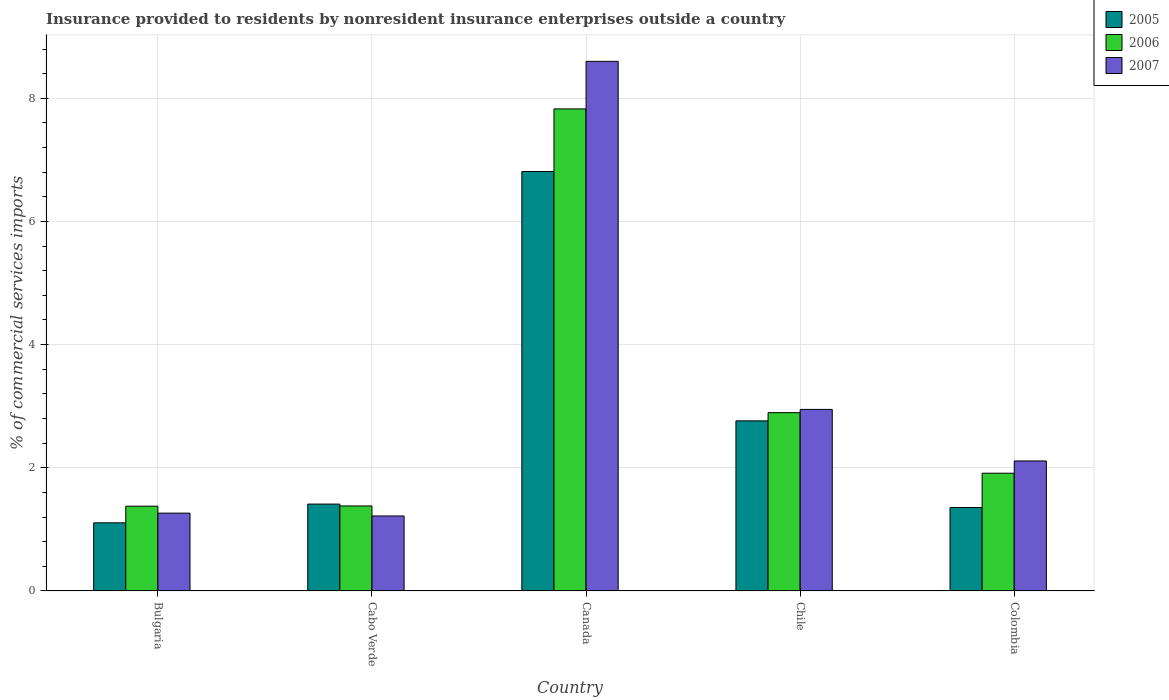How many groups of bars are there?
Your response must be concise. 5. Are the number of bars on each tick of the X-axis equal?
Provide a short and direct response. Yes. How many bars are there on the 5th tick from the left?
Provide a succinct answer. 3. How many bars are there on the 5th tick from the right?
Provide a short and direct response. 3. What is the label of the 4th group of bars from the left?
Provide a succinct answer. Chile. In how many cases, is the number of bars for a given country not equal to the number of legend labels?
Provide a short and direct response. 0. What is the Insurance provided to residents in 2006 in Cabo Verde?
Offer a very short reply. 1.38. Across all countries, what is the maximum Insurance provided to residents in 2006?
Ensure brevity in your answer.  7.83. Across all countries, what is the minimum Insurance provided to residents in 2006?
Ensure brevity in your answer.  1.38. In which country was the Insurance provided to residents in 2007 minimum?
Offer a terse response. Cabo Verde. What is the total Insurance provided to residents in 2005 in the graph?
Your answer should be compact. 13.44. What is the difference between the Insurance provided to residents in 2007 in Bulgaria and that in Chile?
Provide a succinct answer. -1.68. What is the difference between the Insurance provided to residents in 2007 in Chile and the Insurance provided to residents in 2006 in Bulgaria?
Make the answer very short. 1.57. What is the average Insurance provided to residents in 2006 per country?
Keep it short and to the point. 3.08. What is the difference between the Insurance provided to residents of/in 2007 and Insurance provided to residents of/in 2006 in Cabo Verde?
Provide a succinct answer. -0.16. What is the ratio of the Insurance provided to residents in 2005 in Cabo Verde to that in Canada?
Offer a terse response. 0.21. Is the difference between the Insurance provided to residents in 2007 in Chile and Colombia greater than the difference between the Insurance provided to residents in 2006 in Chile and Colombia?
Offer a terse response. No. What is the difference between the highest and the second highest Insurance provided to residents in 2007?
Your response must be concise. 5.65. What is the difference between the highest and the lowest Insurance provided to residents in 2006?
Keep it short and to the point. 6.45. In how many countries, is the Insurance provided to residents in 2005 greater than the average Insurance provided to residents in 2005 taken over all countries?
Your response must be concise. 2. Is the sum of the Insurance provided to residents in 2005 in Bulgaria and Colombia greater than the maximum Insurance provided to residents in 2007 across all countries?
Offer a very short reply. No. What does the 1st bar from the right in Cabo Verde represents?
Provide a succinct answer. 2007. Is it the case that in every country, the sum of the Insurance provided to residents in 2007 and Insurance provided to residents in 2005 is greater than the Insurance provided to residents in 2006?
Keep it short and to the point. Yes. How many countries are there in the graph?
Make the answer very short. 5. Are the values on the major ticks of Y-axis written in scientific E-notation?
Ensure brevity in your answer.  No. Does the graph contain any zero values?
Keep it short and to the point. No. Where does the legend appear in the graph?
Provide a succinct answer. Top right. How many legend labels are there?
Give a very brief answer. 3. How are the legend labels stacked?
Your response must be concise. Vertical. What is the title of the graph?
Offer a terse response. Insurance provided to residents by nonresident insurance enterprises outside a country. Does "1997" appear as one of the legend labels in the graph?
Offer a very short reply. No. What is the label or title of the Y-axis?
Offer a very short reply. % of commercial services imports. What is the % of commercial services imports in 2005 in Bulgaria?
Give a very brief answer. 1.11. What is the % of commercial services imports of 2006 in Bulgaria?
Your response must be concise. 1.38. What is the % of commercial services imports in 2007 in Bulgaria?
Your answer should be very brief. 1.26. What is the % of commercial services imports of 2005 in Cabo Verde?
Your answer should be very brief. 1.41. What is the % of commercial services imports of 2006 in Cabo Verde?
Ensure brevity in your answer.  1.38. What is the % of commercial services imports of 2007 in Cabo Verde?
Provide a short and direct response. 1.22. What is the % of commercial services imports of 2005 in Canada?
Your answer should be very brief. 6.81. What is the % of commercial services imports in 2006 in Canada?
Provide a succinct answer. 7.83. What is the % of commercial services imports of 2007 in Canada?
Provide a short and direct response. 8.6. What is the % of commercial services imports of 2005 in Chile?
Offer a very short reply. 2.76. What is the % of commercial services imports of 2006 in Chile?
Your answer should be compact. 2.89. What is the % of commercial services imports of 2007 in Chile?
Your response must be concise. 2.95. What is the % of commercial services imports in 2005 in Colombia?
Ensure brevity in your answer.  1.35. What is the % of commercial services imports in 2006 in Colombia?
Keep it short and to the point. 1.91. What is the % of commercial services imports of 2007 in Colombia?
Offer a very short reply. 2.11. Across all countries, what is the maximum % of commercial services imports in 2005?
Provide a short and direct response. 6.81. Across all countries, what is the maximum % of commercial services imports of 2006?
Offer a terse response. 7.83. Across all countries, what is the maximum % of commercial services imports of 2007?
Give a very brief answer. 8.6. Across all countries, what is the minimum % of commercial services imports of 2005?
Give a very brief answer. 1.11. Across all countries, what is the minimum % of commercial services imports of 2006?
Your answer should be compact. 1.38. Across all countries, what is the minimum % of commercial services imports of 2007?
Offer a very short reply. 1.22. What is the total % of commercial services imports of 2005 in the graph?
Your answer should be compact. 13.44. What is the total % of commercial services imports in 2006 in the graph?
Make the answer very short. 15.39. What is the total % of commercial services imports of 2007 in the graph?
Give a very brief answer. 16.14. What is the difference between the % of commercial services imports of 2005 in Bulgaria and that in Cabo Verde?
Offer a terse response. -0.3. What is the difference between the % of commercial services imports of 2006 in Bulgaria and that in Cabo Verde?
Offer a very short reply. -0. What is the difference between the % of commercial services imports in 2007 in Bulgaria and that in Cabo Verde?
Offer a very short reply. 0.05. What is the difference between the % of commercial services imports in 2005 in Bulgaria and that in Canada?
Keep it short and to the point. -5.71. What is the difference between the % of commercial services imports of 2006 in Bulgaria and that in Canada?
Offer a terse response. -6.45. What is the difference between the % of commercial services imports of 2007 in Bulgaria and that in Canada?
Your answer should be very brief. -7.34. What is the difference between the % of commercial services imports of 2005 in Bulgaria and that in Chile?
Make the answer very short. -1.66. What is the difference between the % of commercial services imports of 2006 in Bulgaria and that in Chile?
Offer a very short reply. -1.52. What is the difference between the % of commercial services imports in 2007 in Bulgaria and that in Chile?
Ensure brevity in your answer.  -1.68. What is the difference between the % of commercial services imports of 2005 in Bulgaria and that in Colombia?
Offer a terse response. -0.25. What is the difference between the % of commercial services imports in 2006 in Bulgaria and that in Colombia?
Your answer should be very brief. -0.54. What is the difference between the % of commercial services imports in 2007 in Bulgaria and that in Colombia?
Your answer should be compact. -0.85. What is the difference between the % of commercial services imports of 2005 in Cabo Verde and that in Canada?
Give a very brief answer. -5.4. What is the difference between the % of commercial services imports in 2006 in Cabo Verde and that in Canada?
Keep it short and to the point. -6.45. What is the difference between the % of commercial services imports of 2007 in Cabo Verde and that in Canada?
Provide a succinct answer. -7.38. What is the difference between the % of commercial services imports of 2005 in Cabo Verde and that in Chile?
Give a very brief answer. -1.35. What is the difference between the % of commercial services imports of 2006 in Cabo Verde and that in Chile?
Your response must be concise. -1.51. What is the difference between the % of commercial services imports in 2007 in Cabo Verde and that in Chile?
Your answer should be very brief. -1.73. What is the difference between the % of commercial services imports of 2005 in Cabo Verde and that in Colombia?
Offer a very short reply. 0.06. What is the difference between the % of commercial services imports in 2006 in Cabo Verde and that in Colombia?
Ensure brevity in your answer.  -0.53. What is the difference between the % of commercial services imports of 2007 in Cabo Verde and that in Colombia?
Your response must be concise. -0.89. What is the difference between the % of commercial services imports in 2005 in Canada and that in Chile?
Make the answer very short. 4.05. What is the difference between the % of commercial services imports of 2006 in Canada and that in Chile?
Provide a short and direct response. 4.93. What is the difference between the % of commercial services imports of 2007 in Canada and that in Chile?
Ensure brevity in your answer.  5.65. What is the difference between the % of commercial services imports in 2005 in Canada and that in Colombia?
Make the answer very short. 5.46. What is the difference between the % of commercial services imports in 2006 in Canada and that in Colombia?
Make the answer very short. 5.92. What is the difference between the % of commercial services imports of 2007 in Canada and that in Colombia?
Provide a succinct answer. 6.49. What is the difference between the % of commercial services imports of 2005 in Chile and that in Colombia?
Give a very brief answer. 1.41. What is the difference between the % of commercial services imports in 2006 in Chile and that in Colombia?
Your answer should be very brief. 0.98. What is the difference between the % of commercial services imports in 2007 in Chile and that in Colombia?
Offer a terse response. 0.84. What is the difference between the % of commercial services imports in 2005 in Bulgaria and the % of commercial services imports in 2006 in Cabo Verde?
Your answer should be compact. -0.27. What is the difference between the % of commercial services imports of 2005 in Bulgaria and the % of commercial services imports of 2007 in Cabo Verde?
Offer a very short reply. -0.11. What is the difference between the % of commercial services imports in 2006 in Bulgaria and the % of commercial services imports in 2007 in Cabo Verde?
Offer a terse response. 0.16. What is the difference between the % of commercial services imports in 2005 in Bulgaria and the % of commercial services imports in 2006 in Canada?
Your answer should be very brief. -6.72. What is the difference between the % of commercial services imports of 2005 in Bulgaria and the % of commercial services imports of 2007 in Canada?
Keep it short and to the point. -7.49. What is the difference between the % of commercial services imports in 2006 in Bulgaria and the % of commercial services imports in 2007 in Canada?
Ensure brevity in your answer.  -7.22. What is the difference between the % of commercial services imports in 2005 in Bulgaria and the % of commercial services imports in 2006 in Chile?
Offer a terse response. -1.79. What is the difference between the % of commercial services imports of 2005 in Bulgaria and the % of commercial services imports of 2007 in Chile?
Provide a succinct answer. -1.84. What is the difference between the % of commercial services imports in 2006 in Bulgaria and the % of commercial services imports in 2007 in Chile?
Your answer should be very brief. -1.57. What is the difference between the % of commercial services imports in 2005 in Bulgaria and the % of commercial services imports in 2006 in Colombia?
Offer a very short reply. -0.81. What is the difference between the % of commercial services imports in 2005 in Bulgaria and the % of commercial services imports in 2007 in Colombia?
Offer a terse response. -1. What is the difference between the % of commercial services imports of 2006 in Bulgaria and the % of commercial services imports of 2007 in Colombia?
Offer a terse response. -0.73. What is the difference between the % of commercial services imports in 2005 in Cabo Verde and the % of commercial services imports in 2006 in Canada?
Your answer should be very brief. -6.42. What is the difference between the % of commercial services imports of 2005 in Cabo Verde and the % of commercial services imports of 2007 in Canada?
Provide a short and direct response. -7.19. What is the difference between the % of commercial services imports of 2006 in Cabo Verde and the % of commercial services imports of 2007 in Canada?
Offer a terse response. -7.22. What is the difference between the % of commercial services imports of 2005 in Cabo Verde and the % of commercial services imports of 2006 in Chile?
Provide a short and direct response. -1.48. What is the difference between the % of commercial services imports in 2005 in Cabo Verde and the % of commercial services imports in 2007 in Chile?
Ensure brevity in your answer.  -1.54. What is the difference between the % of commercial services imports of 2006 in Cabo Verde and the % of commercial services imports of 2007 in Chile?
Offer a very short reply. -1.57. What is the difference between the % of commercial services imports of 2005 in Cabo Verde and the % of commercial services imports of 2006 in Colombia?
Your answer should be very brief. -0.5. What is the difference between the % of commercial services imports of 2005 in Cabo Verde and the % of commercial services imports of 2007 in Colombia?
Your response must be concise. -0.7. What is the difference between the % of commercial services imports of 2006 in Cabo Verde and the % of commercial services imports of 2007 in Colombia?
Your answer should be very brief. -0.73. What is the difference between the % of commercial services imports in 2005 in Canada and the % of commercial services imports in 2006 in Chile?
Provide a short and direct response. 3.92. What is the difference between the % of commercial services imports in 2005 in Canada and the % of commercial services imports in 2007 in Chile?
Ensure brevity in your answer.  3.86. What is the difference between the % of commercial services imports of 2006 in Canada and the % of commercial services imports of 2007 in Chile?
Your answer should be very brief. 4.88. What is the difference between the % of commercial services imports of 2005 in Canada and the % of commercial services imports of 2006 in Colombia?
Your answer should be compact. 4.9. What is the difference between the % of commercial services imports of 2005 in Canada and the % of commercial services imports of 2007 in Colombia?
Provide a succinct answer. 4.7. What is the difference between the % of commercial services imports of 2006 in Canada and the % of commercial services imports of 2007 in Colombia?
Your response must be concise. 5.72. What is the difference between the % of commercial services imports in 2005 in Chile and the % of commercial services imports in 2006 in Colombia?
Your response must be concise. 0.85. What is the difference between the % of commercial services imports in 2005 in Chile and the % of commercial services imports in 2007 in Colombia?
Offer a very short reply. 0.65. What is the difference between the % of commercial services imports of 2006 in Chile and the % of commercial services imports of 2007 in Colombia?
Provide a short and direct response. 0.78. What is the average % of commercial services imports in 2005 per country?
Keep it short and to the point. 2.69. What is the average % of commercial services imports in 2006 per country?
Provide a succinct answer. 3.08. What is the average % of commercial services imports of 2007 per country?
Your answer should be very brief. 3.23. What is the difference between the % of commercial services imports in 2005 and % of commercial services imports in 2006 in Bulgaria?
Ensure brevity in your answer.  -0.27. What is the difference between the % of commercial services imports of 2005 and % of commercial services imports of 2007 in Bulgaria?
Your response must be concise. -0.16. What is the difference between the % of commercial services imports of 2006 and % of commercial services imports of 2007 in Bulgaria?
Your answer should be very brief. 0.11. What is the difference between the % of commercial services imports of 2005 and % of commercial services imports of 2006 in Cabo Verde?
Give a very brief answer. 0.03. What is the difference between the % of commercial services imports in 2005 and % of commercial services imports in 2007 in Cabo Verde?
Keep it short and to the point. 0.19. What is the difference between the % of commercial services imports in 2006 and % of commercial services imports in 2007 in Cabo Verde?
Ensure brevity in your answer.  0.16. What is the difference between the % of commercial services imports of 2005 and % of commercial services imports of 2006 in Canada?
Keep it short and to the point. -1.02. What is the difference between the % of commercial services imports in 2005 and % of commercial services imports in 2007 in Canada?
Make the answer very short. -1.79. What is the difference between the % of commercial services imports of 2006 and % of commercial services imports of 2007 in Canada?
Provide a short and direct response. -0.77. What is the difference between the % of commercial services imports in 2005 and % of commercial services imports in 2006 in Chile?
Keep it short and to the point. -0.13. What is the difference between the % of commercial services imports in 2005 and % of commercial services imports in 2007 in Chile?
Offer a terse response. -0.19. What is the difference between the % of commercial services imports in 2006 and % of commercial services imports in 2007 in Chile?
Offer a very short reply. -0.05. What is the difference between the % of commercial services imports of 2005 and % of commercial services imports of 2006 in Colombia?
Give a very brief answer. -0.56. What is the difference between the % of commercial services imports of 2005 and % of commercial services imports of 2007 in Colombia?
Your response must be concise. -0.76. What is the difference between the % of commercial services imports in 2006 and % of commercial services imports in 2007 in Colombia?
Your answer should be compact. -0.2. What is the ratio of the % of commercial services imports of 2005 in Bulgaria to that in Cabo Verde?
Your answer should be compact. 0.78. What is the ratio of the % of commercial services imports in 2007 in Bulgaria to that in Cabo Verde?
Keep it short and to the point. 1.04. What is the ratio of the % of commercial services imports in 2005 in Bulgaria to that in Canada?
Offer a very short reply. 0.16. What is the ratio of the % of commercial services imports of 2006 in Bulgaria to that in Canada?
Provide a short and direct response. 0.18. What is the ratio of the % of commercial services imports in 2007 in Bulgaria to that in Canada?
Your response must be concise. 0.15. What is the ratio of the % of commercial services imports in 2005 in Bulgaria to that in Chile?
Offer a very short reply. 0.4. What is the ratio of the % of commercial services imports in 2006 in Bulgaria to that in Chile?
Ensure brevity in your answer.  0.48. What is the ratio of the % of commercial services imports of 2007 in Bulgaria to that in Chile?
Ensure brevity in your answer.  0.43. What is the ratio of the % of commercial services imports in 2005 in Bulgaria to that in Colombia?
Ensure brevity in your answer.  0.82. What is the ratio of the % of commercial services imports of 2006 in Bulgaria to that in Colombia?
Provide a short and direct response. 0.72. What is the ratio of the % of commercial services imports in 2007 in Bulgaria to that in Colombia?
Give a very brief answer. 0.6. What is the ratio of the % of commercial services imports of 2005 in Cabo Verde to that in Canada?
Offer a very short reply. 0.21. What is the ratio of the % of commercial services imports in 2006 in Cabo Verde to that in Canada?
Ensure brevity in your answer.  0.18. What is the ratio of the % of commercial services imports in 2007 in Cabo Verde to that in Canada?
Give a very brief answer. 0.14. What is the ratio of the % of commercial services imports of 2005 in Cabo Verde to that in Chile?
Keep it short and to the point. 0.51. What is the ratio of the % of commercial services imports of 2006 in Cabo Verde to that in Chile?
Ensure brevity in your answer.  0.48. What is the ratio of the % of commercial services imports of 2007 in Cabo Verde to that in Chile?
Your response must be concise. 0.41. What is the ratio of the % of commercial services imports of 2005 in Cabo Verde to that in Colombia?
Your answer should be very brief. 1.04. What is the ratio of the % of commercial services imports of 2006 in Cabo Verde to that in Colombia?
Ensure brevity in your answer.  0.72. What is the ratio of the % of commercial services imports in 2007 in Cabo Verde to that in Colombia?
Your answer should be very brief. 0.58. What is the ratio of the % of commercial services imports of 2005 in Canada to that in Chile?
Offer a terse response. 2.47. What is the ratio of the % of commercial services imports of 2006 in Canada to that in Chile?
Provide a succinct answer. 2.7. What is the ratio of the % of commercial services imports of 2007 in Canada to that in Chile?
Give a very brief answer. 2.92. What is the ratio of the % of commercial services imports in 2005 in Canada to that in Colombia?
Make the answer very short. 5.03. What is the ratio of the % of commercial services imports of 2006 in Canada to that in Colombia?
Ensure brevity in your answer.  4.1. What is the ratio of the % of commercial services imports of 2007 in Canada to that in Colombia?
Provide a short and direct response. 4.07. What is the ratio of the % of commercial services imports in 2005 in Chile to that in Colombia?
Your response must be concise. 2.04. What is the ratio of the % of commercial services imports of 2006 in Chile to that in Colombia?
Your response must be concise. 1.51. What is the ratio of the % of commercial services imports of 2007 in Chile to that in Colombia?
Provide a succinct answer. 1.4. What is the difference between the highest and the second highest % of commercial services imports of 2005?
Give a very brief answer. 4.05. What is the difference between the highest and the second highest % of commercial services imports of 2006?
Your answer should be very brief. 4.93. What is the difference between the highest and the second highest % of commercial services imports in 2007?
Give a very brief answer. 5.65. What is the difference between the highest and the lowest % of commercial services imports in 2005?
Give a very brief answer. 5.71. What is the difference between the highest and the lowest % of commercial services imports in 2006?
Provide a short and direct response. 6.45. What is the difference between the highest and the lowest % of commercial services imports of 2007?
Offer a very short reply. 7.38. 